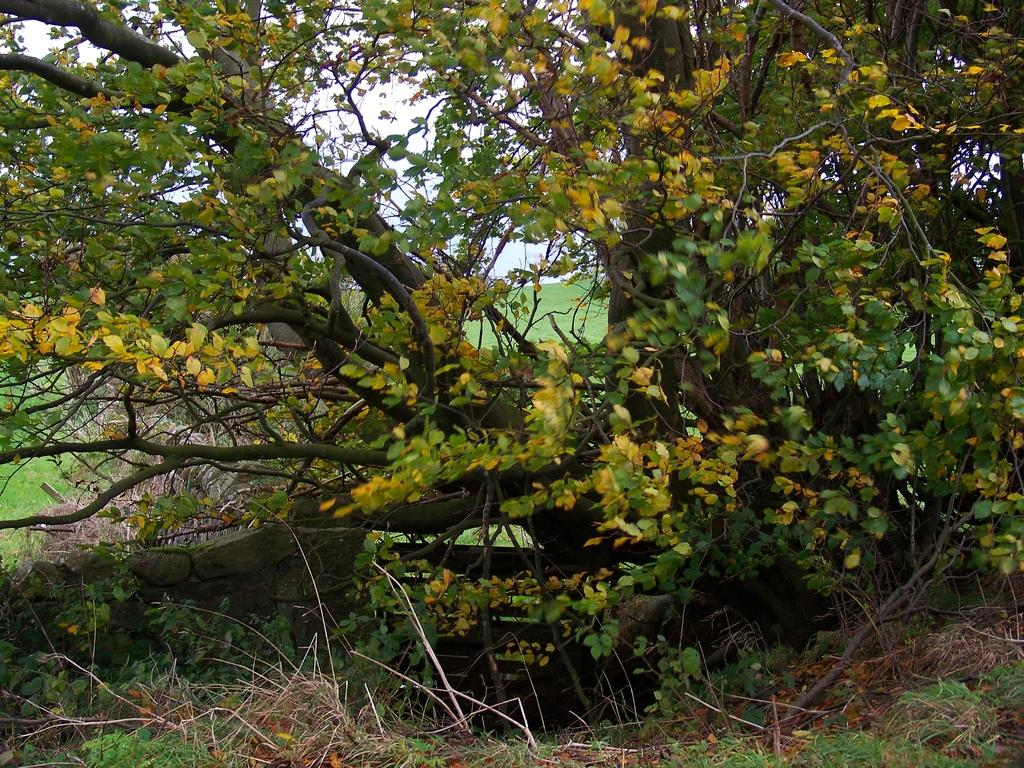What type of vegetation can be seen in the image? There are trees in the image. What is the color of the leaves on the trees? The trees have green leaves. What is present at the bottom of the image? There is grass at the bottom of the image. What is the color of the grass in the background? The grass in the background is green. What can be seen in the sky in the image? There are clouds in the sky. How many clocks are hanging from the trees in the image? There are no clocks hanging from the trees in the image. Can you describe the bite marks on the leaves of the trees? There are no bite marks on the leaves of the trees in the image. 